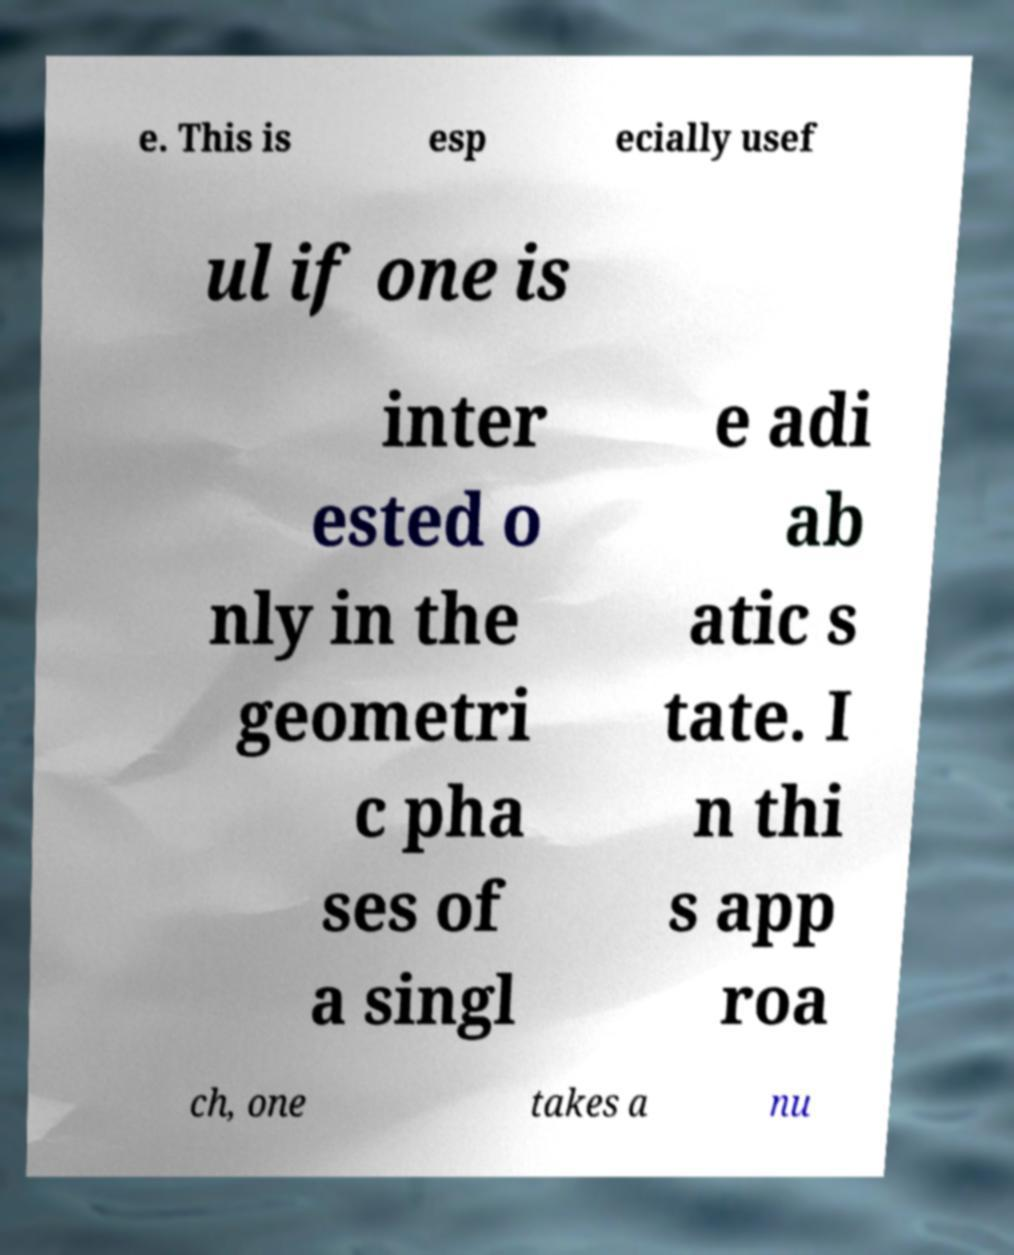For documentation purposes, I need the text within this image transcribed. Could you provide that? e. This is esp ecially usef ul if one is inter ested o nly in the geometri c pha ses of a singl e adi ab atic s tate. I n thi s app roa ch, one takes a nu 